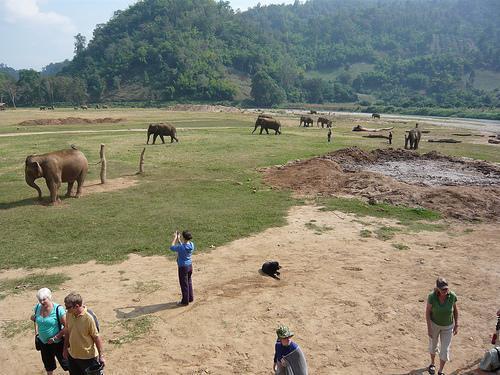How many humans are in the photo?
Give a very brief answer. 7. 